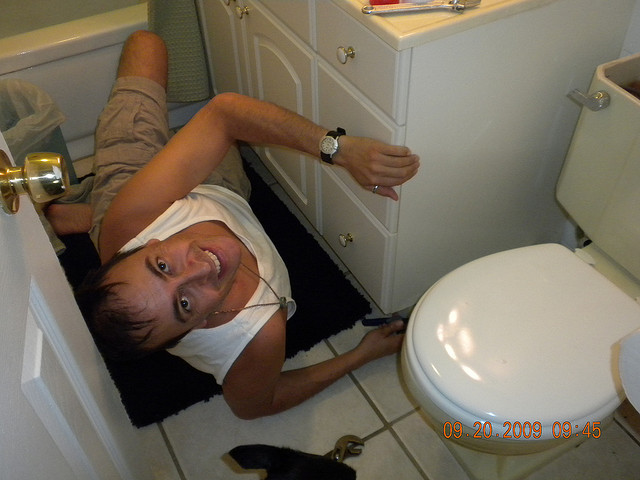Identify and read out the text in this image. 09.20.2009 09:45 